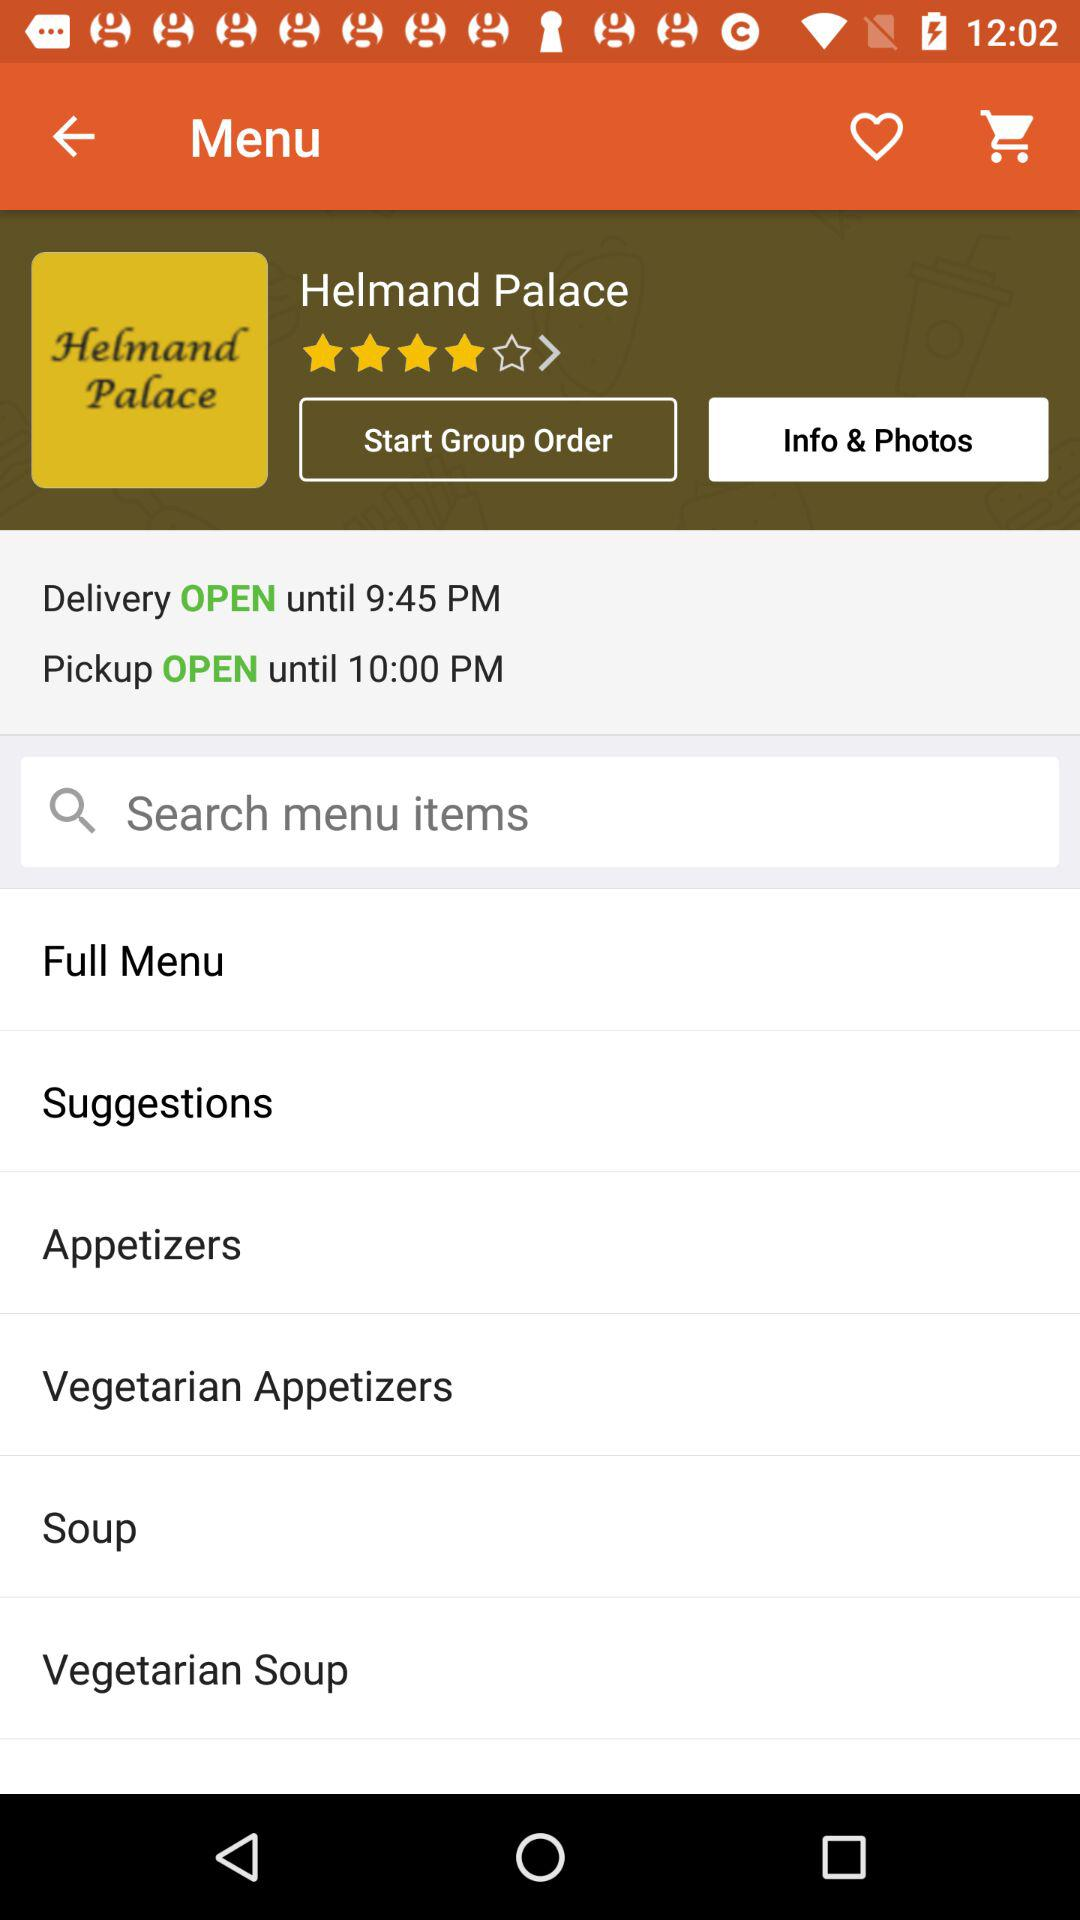Until when is the delivery open? The delivery is open until 9:45 p.m. 